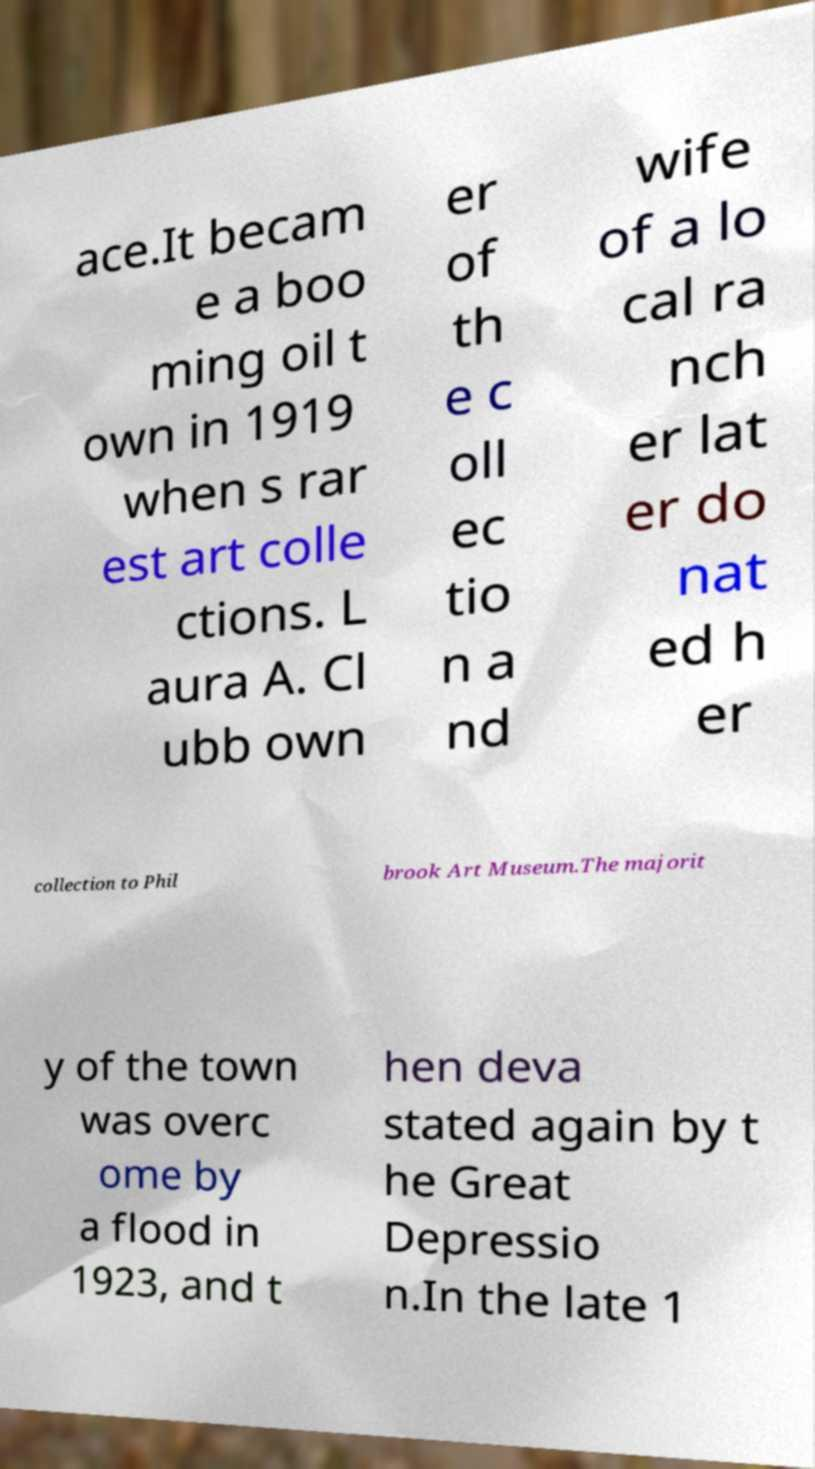Please read and relay the text visible in this image. What does it say? ace.It becam e a boo ming oil t own in 1919 when s rar est art colle ctions. L aura A. Cl ubb own er of th e c oll ec tio n a nd wife of a lo cal ra nch er lat er do nat ed h er collection to Phil brook Art Museum.The majorit y of the town was overc ome by a flood in 1923, and t hen deva stated again by t he Great Depressio n.In the late 1 